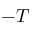<formula> <loc_0><loc_0><loc_500><loc_500>- T</formula> 